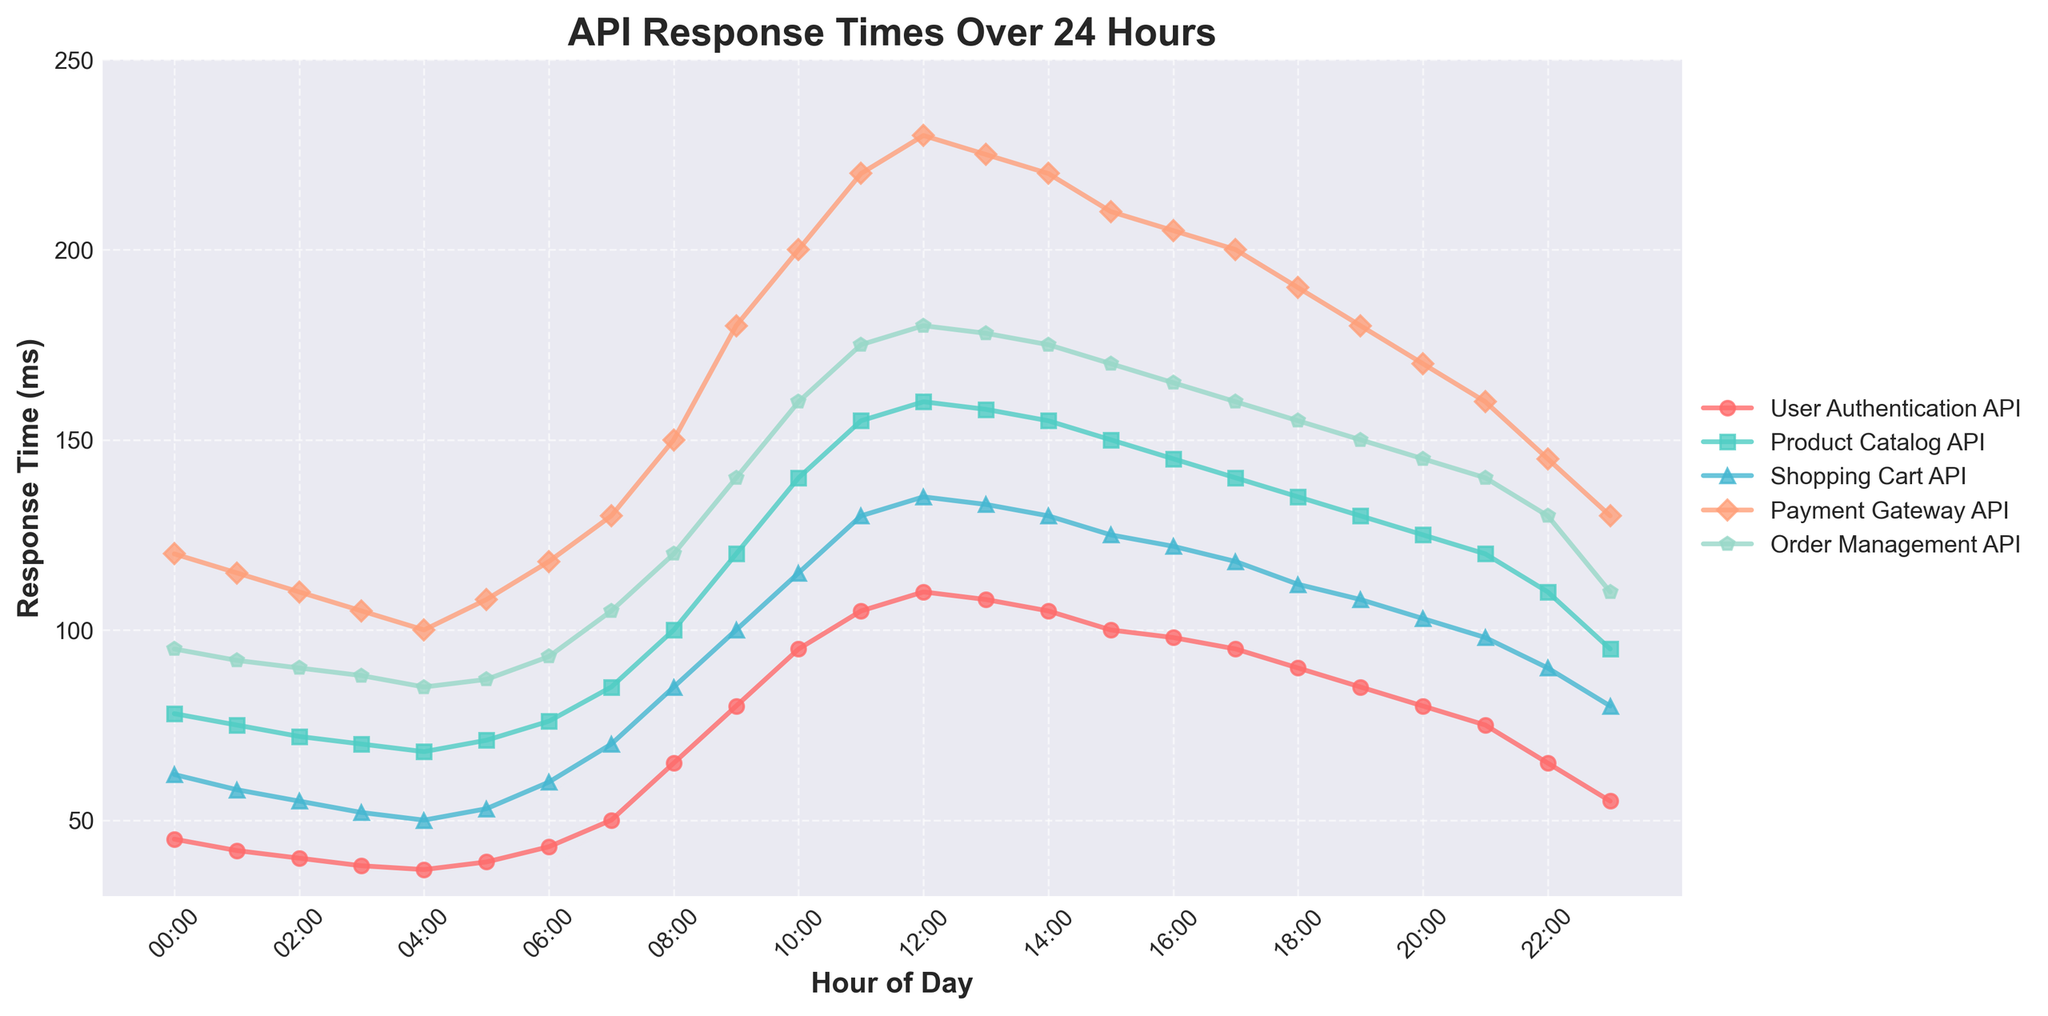Which API has the highest average response time at 11:00? At 11:00, the y-values for each API must be observed to determine which one is the highest. These values are User Authentication (105 ms), Product Catalog (155 ms), Shopping Cart (130 ms), Payment Gateway (220 ms), and Order Management (175 ms). Reviewing these, the Payment Gateway API has the highest response time.
Answer: Payment Gateway API How does the response time for the User Authentication API at 13:00 compare to its response time at 19:00? To compare the response times at 13:00 and 19:00, observe the y-values for User Authentication API at both times. At 13:00, it's 108 ms, and at 19:00, it's 85 ms. Thus, the response time at 13:00 is higher.
Answer: 13:00 is higher What is the average response time of the Product Catalog API between 14:00 and 16:00? Average calculation is needed for the Product Catalog response times at 14:00, 15:00, and 16:00. These times are 155 ms, 150 ms, and 145 ms respectively. Average = (155 + 150 + 145) / 3 = 150 ms.
Answer: 150 ms Which API has the most significant decrease in response time from 10:00 to 11:00? Calculate the difference in response time for each API between 10:00 and 11:00. User Authentication: 105 - 95 = 10 ms, Product Catalog: 155 - 140 = 15 ms, Shopping Cart: 130 - 115 = 15 ms, Payment Gateway: 220 - 200 = 20 ms, Order Management: 175 - 160 = 15 ms. The Payment Gateway API has the largest decrease.
Answer: Payment Gateway API At what time does the Shopping Cart API experience its highest response time? Review the y-values corresponding to each hour for the Shopping Cart API. The highest value occurs at 12:00 with 135 ms.
Answer: 12:00 Which API shows the smallest response time at 7:00? Compare the response times at 7:00 for each API: User Authentication (50 ms), Product Catalog (85 ms), Shopping Cart (70 ms), Payment Gateway (130 ms), Order Management (105 ms). User Authentication API has the smallest response time.
Answer: User Authentication API What is the difference in response time between the Product Catalog API and the Order Management API at 20:00? Subtract the response time for Order Management API from the response time for Product Catalog API at 20:00. Product Catalog: 125 ms, Order Management: 145 ms. Difference: 145 - 125 = 20 ms.
Answer: 20 ms Which hour records the lowest average response time across all APIs? To find this, average the response times for each hour and determine the lowest. Hour 4: (37+68+50+100+85)/5=68 ms, Hour 5: (39+71+53+108+87)/5=71.6 ms. Among all calculations, hour 4 has the lowest average of 68 ms.
Answer: 4:00 